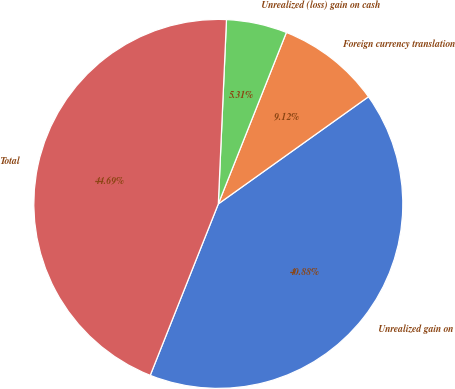Convert chart to OTSL. <chart><loc_0><loc_0><loc_500><loc_500><pie_chart><fcel>Unrealized gain on<fcel>Foreign currency translation<fcel>Unrealized (loss) gain on cash<fcel>Total<nl><fcel>40.88%<fcel>9.12%<fcel>5.31%<fcel>44.69%<nl></chart> 